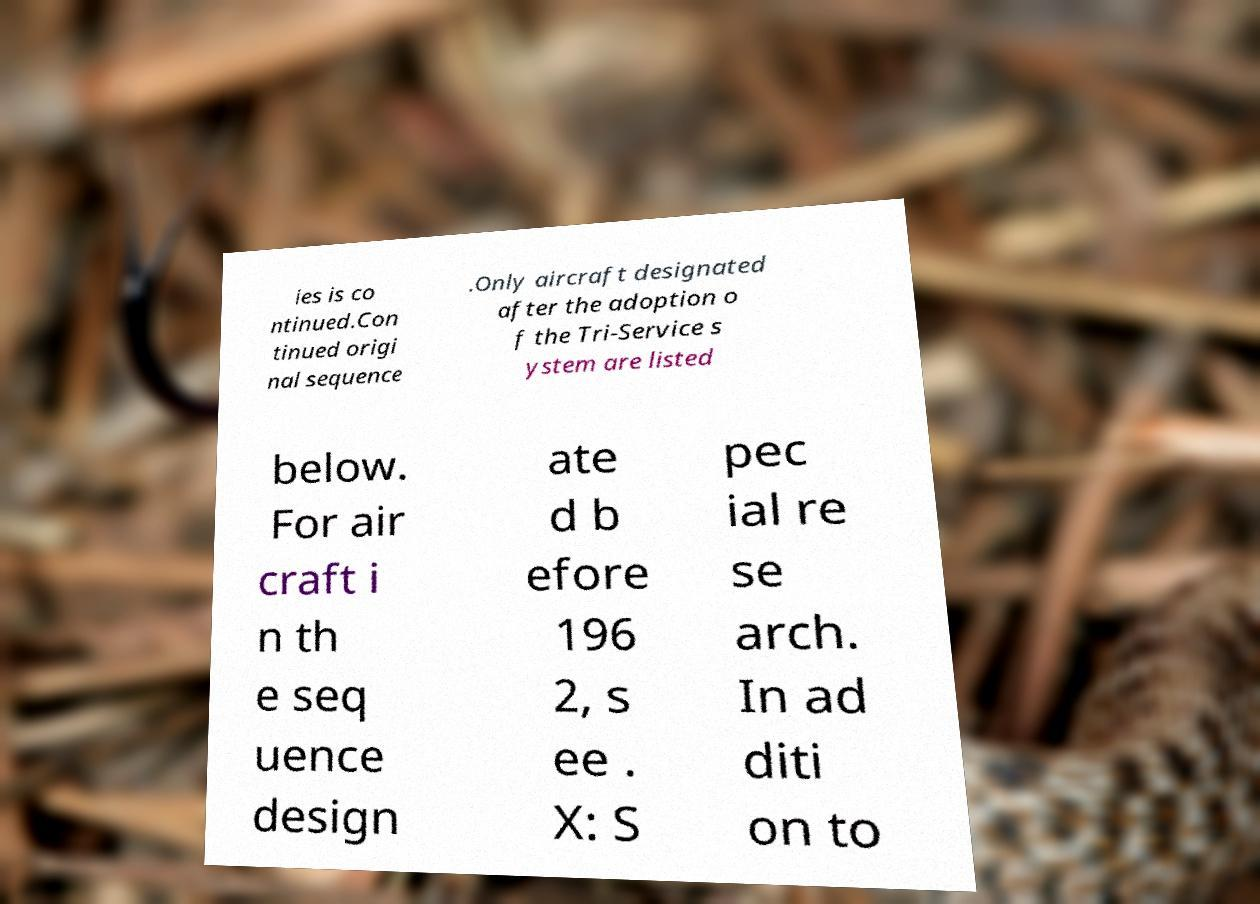For documentation purposes, I need the text within this image transcribed. Could you provide that? ies is co ntinued.Con tinued origi nal sequence .Only aircraft designated after the adoption o f the Tri-Service s ystem are listed below. For air craft i n th e seq uence design ate d b efore 196 2, s ee . X: S pec ial re se arch. In ad diti on to 